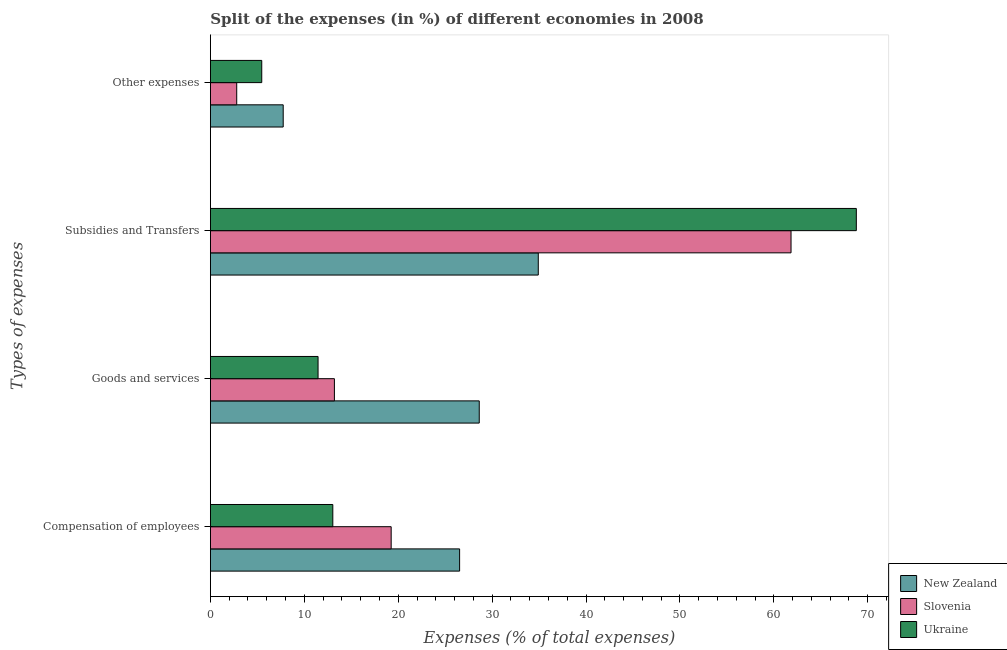Are the number of bars per tick equal to the number of legend labels?
Provide a succinct answer. Yes. What is the label of the 4th group of bars from the top?
Offer a terse response. Compensation of employees. What is the percentage of amount spent on compensation of employees in Ukraine?
Make the answer very short. 13.04. Across all countries, what is the maximum percentage of amount spent on compensation of employees?
Provide a succinct answer. 26.54. Across all countries, what is the minimum percentage of amount spent on compensation of employees?
Your answer should be compact. 13.04. In which country was the percentage of amount spent on other expenses maximum?
Your answer should be compact. New Zealand. In which country was the percentage of amount spent on subsidies minimum?
Offer a terse response. New Zealand. What is the total percentage of amount spent on other expenses in the graph?
Keep it short and to the point. 16.03. What is the difference between the percentage of amount spent on subsidies in Ukraine and that in New Zealand?
Your answer should be compact. 33.87. What is the difference between the percentage of amount spent on subsidies in Slovenia and the percentage of amount spent on goods and services in New Zealand?
Offer a terse response. 33.2. What is the average percentage of amount spent on other expenses per country?
Your answer should be very brief. 5.34. What is the difference between the percentage of amount spent on other expenses and percentage of amount spent on goods and services in Slovenia?
Your answer should be compact. -10.4. What is the ratio of the percentage of amount spent on other expenses in New Zealand to that in Ukraine?
Your answer should be very brief. 1.42. What is the difference between the highest and the second highest percentage of amount spent on goods and services?
Ensure brevity in your answer.  15.42. What is the difference between the highest and the lowest percentage of amount spent on compensation of employees?
Provide a short and direct response. 13.5. In how many countries, is the percentage of amount spent on subsidies greater than the average percentage of amount spent on subsidies taken over all countries?
Provide a short and direct response. 2. What does the 3rd bar from the top in Compensation of employees represents?
Ensure brevity in your answer.  New Zealand. What does the 3rd bar from the bottom in Other expenses represents?
Your answer should be compact. Ukraine. What is the difference between two consecutive major ticks on the X-axis?
Your answer should be compact. 10. Are the values on the major ticks of X-axis written in scientific E-notation?
Offer a terse response. No. Does the graph contain any zero values?
Make the answer very short. No. Does the graph contain grids?
Offer a terse response. No. Where does the legend appear in the graph?
Ensure brevity in your answer.  Bottom right. How many legend labels are there?
Your answer should be compact. 3. How are the legend labels stacked?
Provide a succinct answer. Vertical. What is the title of the graph?
Ensure brevity in your answer.  Split of the expenses (in %) of different economies in 2008. Does "Estonia" appear as one of the legend labels in the graph?
Offer a very short reply. No. What is the label or title of the X-axis?
Ensure brevity in your answer.  Expenses (% of total expenses). What is the label or title of the Y-axis?
Your answer should be compact. Types of expenses. What is the Expenses (% of total expenses) in New Zealand in Compensation of employees?
Make the answer very short. 26.54. What is the Expenses (% of total expenses) in Slovenia in Compensation of employees?
Make the answer very short. 19.25. What is the Expenses (% of total expenses) of Ukraine in Compensation of employees?
Make the answer very short. 13.04. What is the Expenses (% of total expenses) of New Zealand in Goods and services?
Ensure brevity in your answer.  28.63. What is the Expenses (% of total expenses) of Slovenia in Goods and services?
Ensure brevity in your answer.  13.21. What is the Expenses (% of total expenses) in Ukraine in Goods and services?
Give a very brief answer. 11.47. What is the Expenses (% of total expenses) in New Zealand in Subsidies and Transfers?
Give a very brief answer. 34.91. What is the Expenses (% of total expenses) of Slovenia in Subsidies and Transfers?
Provide a short and direct response. 61.83. What is the Expenses (% of total expenses) in Ukraine in Subsidies and Transfers?
Keep it short and to the point. 68.78. What is the Expenses (% of total expenses) in New Zealand in Other expenses?
Make the answer very short. 7.75. What is the Expenses (% of total expenses) of Slovenia in Other expenses?
Keep it short and to the point. 2.8. What is the Expenses (% of total expenses) in Ukraine in Other expenses?
Your answer should be very brief. 5.47. Across all Types of expenses, what is the maximum Expenses (% of total expenses) of New Zealand?
Offer a very short reply. 34.91. Across all Types of expenses, what is the maximum Expenses (% of total expenses) in Slovenia?
Give a very brief answer. 61.83. Across all Types of expenses, what is the maximum Expenses (% of total expenses) of Ukraine?
Give a very brief answer. 68.78. Across all Types of expenses, what is the minimum Expenses (% of total expenses) of New Zealand?
Offer a terse response. 7.75. Across all Types of expenses, what is the minimum Expenses (% of total expenses) in Slovenia?
Your answer should be very brief. 2.8. Across all Types of expenses, what is the minimum Expenses (% of total expenses) of Ukraine?
Provide a short and direct response. 5.47. What is the total Expenses (% of total expenses) of New Zealand in the graph?
Your response must be concise. 97.84. What is the total Expenses (% of total expenses) in Slovenia in the graph?
Make the answer very short. 97.09. What is the total Expenses (% of total expenses) of Ukraine in the graph?
Keep it short and to the point. 98.75. What is the difference between the Expenses (% of total expenses) of New Zealand in Compensation of employees and that in Goods and services?
Your response must be concise. -2.09. What is the difference between the Expenses (% of total expenses) in Slovenia in Compensation of employees and that in Goods and services?
Offer a terse response. 6.04. What is the difference between the Expenses (% of total expenses) of Ukraine in Compensation of employees and that in Goods and services?
Ensure brevity in your answer.  1.57. What is the difference between the Expenses (% of total expenses) of New Zealand in Compensation of employees and that in Subsidies and Transfers?
Offer a terse response. -8.38. What is the difference between the Expenses (% of total expenses) of Slovenia in Compensation of employees and that in Subsidies and Transfers?
Offer a very short reply. -42.58. What is the difference between the Expenses (% of total expenses) in Ukraine in Compensation of employees and that in Subsidies and Transfers?
Your answer should be compact. -55.74. What is the difference between the Expenses (% of total expenses) in New Zealand in Compensation of employees and that in Other expenses?
Your answer should be compact. 18.78. What is the difference between the Expenses (% of total expenses) of Slovenia in Compensation of employees and that in Other expenses?
Keep it short and to the point. 16.45. What is the difference between the Expenses (% of total expenses) in Ukraine in Compensation of employees and that in Other expenses?
Make the answer very short. 7.57. What is the difference between the Expenses (% of total expenses) in New Zealand in Goods and services and that in Subsidies and Transfers?
Offer a terse response. -6.29. What is the difference between the Expenses (% of total expenses) of Slovenia in Goods and services and that in Subsidies and Transfers?
Your answer should be very brief. -48.62. What is the difference between the Expenses (% of total expenses) of Ukraine in Goods and services and that in Subsidies and Transfers?
Your response must be concise. -57.32. What is the difference between the Expenses (% of total expenses) of New Zealand in Goods and services and that in Other expenses?
Your response must be concise. 20.88. What is the difference between the Expenses (% of total expenses) in Slovenia in Goods and services and that in Other expenses?
Make the answer very short. 10.4. What is the difference between the Expenses (% of total expenses) in Ukraine in Goods and services and that in Other expenses?
Make the answer very short. 6. What is the difference between the Expenses (% of total expenses) of New Zealand in Subsidies and Transfers and that in Other expenses?
Give a very brief answer. 27.16. What is the difference between the Expenses (% of total expenses) of Slovenia in Subsidies and Transfers and that in Other expenses?
Your answer should be very brief. 59.02. What is the difference between the Expenses (% of total expenses) in Ukraine in Subsidies and Transfers and that in Other expenses?
Your answer should be compact. 63.31. What is the difference between the Expenses (% of total expenses) of New Zealand in Compensation of employees and the Expenses (% of total expenses) of Slovenia in Goods and services?
Your response must be concise. 13.33. What is the difference between the Expenses (% of total expenses) in New Zealand in Compensation of employees and the Expenses (% of total expenses) in Ukraine in Goods and services?
Your answer should be compact. 15.07. What is the difference between the Expenses (% of total expenses) in Slovenia in Compensation of employees and the Expenses (% of total expenses) in Ukraine in Goods and services?
Give a very brief answer. 7.78. What is the difference between the Expenses (% of total expenses) in New Zealand in Compensation of employees and the Expenses (% of total expenses) in Slovenia in Subsidies and Transfers?
Make the answer very short. -35.29. What is the difference between the Expenses (% of total expenses) in New Zealand in Compensation of employees and the Expenses (% of total expenses) in Ukraine in Subsidies and Transfers?
Your answer should be compact. -42.24. What is the difference between the Expenses (% of total expenses) of Slovenia in Compensation of employees and the Expenses (% of total expenses) of Ukraine in Subsidies and Transfers?
Your answer should be compact. -49.53. What is the difference between the Expenses (% of total expenses) in New Zealand in Compensation of employees and the Expenses (% of total expenses) in Slovenia in Other expenses?
Offer a very short reply. 23.73. What is the difference between the Expenses (% of total expenses) in New Zealand in Compensation of employees and the Expenses (% of total expenses) in Ukraine in Other expenses?
Your answer should be very brief. 21.07. What is the difference between the Expenses (% of total expenses) in Slovenia in Compensation of employees and the Expenses (% of total expenses) in Ukraine in Other expenses?
Your answer should be very brief. 13.78. What is the difference between the Expenses (% of total expenses) of New Zealand in Goods and services and the Expenses (% of total expenses) of Slovenia in Subsidies and Transfers?
Provide a short and direct response. -33.2. What is the difference between the Expenses (% of total expenses) in New Zealand in Goods and services and the Expenses (% of total expenses) in Ukraine in Subsidies and Transfers?
Your answer should be very brief. -40.15. What is the difference between the Expenses (% of total expenses) of Slovenia in Goods and services and the Expenses (% of total expenses) of Ukraine in Subsidies and Transfers?
Provide a succinct answer. -55.57. What is the difference between the Expenses (% of total expenses) in New Zealand in Goods and services and the Expenses (% of total expenses) in Slovenia in Other expenses?
Your response must be concise. 25.82. What is the difference between the Expenses (% of total expenses) of New Zealand in Goods and services and the Expenses (% of total expenses) of Ukraine in Other expenses?
Provide a succinct answer. 23.16. What is the difference between the Expenses (% of total expenses) in Slovenia in Goods and services and the Expenses (% of total expenses) in Ukraine in Other expenses?
Your response must be concise. 7.74. What is the difference between the Expenses (% of total expenses) in New Zealand in Subsidies and Transfers and the Expenses (% of total expenses) in Slovenia in Other expenses?
Keep it short and to the point. 32.11. What is the difference between the Expenses (% of total expenses) in New Zealand in Subsidies and Transfers and the Expenses (% of total expenses) in Ukraine in Other expenses?
Your response must be concise. 29.45. What is the difference between the Expenses (% of total expenses) of Slovenia in Subsidies and Transfers and the Expenses (% of total expenses) of Ukraine in Other expenses?
Ensure brevity in your answer.  56.36. What is the average Expenses (% of total expenses) of New Zealand per Types of expenses?
Your response must be concise. 24.46. What is the average Expenses (% of total expenses) of Slovenia per Types of expenses?
Offer a very short reply. 24.27. What is the average Expenses (% of total expenses) of Ukraine per Types of expenses?
Provide a succinct answer. 24.69. What is the difference between the Expenses (% of total expenses) of New Zealand and Expenses (% of total expenses) of Slovenia in Compensation of employees?
Keep it short and to the point. 7.29. What is the difference between the Expenses (% of total expenses) in New Zealand and Expenses (% of total expenses) in Ukraine in Compensation of employees?
Keep it short and to the point. 13.5. What is the difference between the Expenses (% of total expenses) of Slovenia and Expenses (% of total expenses) of Ukraine in Compensation of employees?
Offer a terse response. 6.21. What is the difference between the Expenses (% of total expenses) in New Zealand and Expenses (% of total expenses) in Slovenia in Goods and services?
Offer a terse response. 15.42. What is the difference between the Expenses (% of total expenses) of New Zealand and Expenses (% of total expenses) of Ukraine in Goods and services?
Your answer should be very brief. 17.16. What is the difference between the Expenses (% of total expenses) in Slovenia and Expenses (% of total expenses) in Ukraine in Goods and services?
Provide a succinct answer. 1.74. What is the difference between the Expenses (% of total expenses) in New Zealand and Expenses (% of total expenses) in Slovenia in Subsidies and Transfers?
Provide a short and direct response. -26.91. What is the difference between the Expenses (% of total expenses) of New Zealand and Expenses (% of total expenses) of Ukraine in Subsidies and Transfers?
Your answer should be very brief. -33.87. What is the difference between the Expenses (% of total expenses) of Slovenia and Expenses (% of total expenses) of Ukraine in Subsidies and Transfers?
Offer a terse response. -6.95. What is the difference between the Expenses (% of total expenses) of New Zealand and Expenses (% of total expenses) of Slovenia in Other expenses?
Keep it short and to the point. 4.95. What is the difference between the Expenses (% of total expenses) in New Zealand and Expenses (% of total expenses) in Ukraine in Other expenses?
Provide a succinct answer. 2.28. What is the difference between the Expenses (% of total expenses) of Slovenia and Expenses (% of total expenses) of Ukraine in Other expenses?
Ensure brevity in your answer.  -2.67. What is the ratio of the Expenses (% of total expenses) of New Zealand in Compensation of employees to that in Goods and services?
Your response must be concise. 0.93. What is the ratio of the Expenses (% of total expenses) in Slovenia in Compensation of employees to that in Goods and services?
Provide a short and direct response. 1.46. What is the ratio of the Expenses (% of total expenses) of Ukraine in Compensation of employees to that in Goods and services?
Provide a short and direct response. 1.14. What is the ratio of the Expenses (% of total expenses) in New Zealand in Compensation of employees to that in Subsidies and Transfers?
Provide a succinct answer. 0.76. What is the ratio of the Expenses (% of total expenses) of Slovenia in Compensation of employees to that in Subsidies and Transfers?
Your response must be concise. 0.31. What is the ratio of the Expenses (% of total expenses) in Ukraine in Compensation of employees to that in Subsidies and Transfers?
Your answer should be compact. 0.19. What is the ratio of the Expenses (% of total expenses) in New Zealand in Compensation of employees to that in Other expenses?
Your answer should be very brief. 3.42. What is the ratio of the Expenses (% of total expenses) of Slovenia in Compensation of employees to that in Other expenses?
Your answer should be compact. 6.86. What is the ratio of the Expenses (% of total expenses) of Ukraine in Compensation of employees to that in Other expenses?
Your answer should be compact. 2.38. What is the ratio of the Expenses (% of total expenses) of New Zealand in Goods and services to that in Subsidies and Transfers?
Your answer should be very brief. 0.82. What is the ratio of the Expenses (% of total expenses) of Slovenia in Goods and services to that in Subsidies and Transfers?
Your answer should be compact. 0.21. What is the ratio of the Expenses (% of total expenses) in New Zealand in Goods and services to that in Other expenses?
Your response must be concise. 3.69. What is the ratio of the Expenses (% of total expenses) in Slovenia in Goods and services to that in Other expenses?
Ensure brevity in your answer.  4.71. What is the ratio of the Expenses (% of total expenses) of Ukraine in Goods and services to that in Other expenses?
Your answer should be very brief. 2.1. What is the ratio of the Expenses (% of total expenses) of New Zealand in Subsidies and Transfers to that in Other expenses?
Offer a terse response. 4.5. What is the ratio of the Expenses (% of total expenses) in Slovenia in Subsidies and Transfers to that in Other expenses?
Make the answer very short. 22.05. What is the ratio of the Expenses (% of total expenses) of Ukraine in Subsidies and Transfers to that in Other expenses?
Offer a very short reply. 12.57. What is the difference between the highest and the second highest Expenses (% of total expenses) in New Zealand?
Offer a terse response. 6.29. What is the difference between the highest and the second highest Expenses (% of total expenses) of Slovenia?
Keep it short and to the point. 42.58. What is the difference between the highest and the second highest Expenses (% of total expenses) in Ukraine?
Provide a succinct answer. 55.74. What is the difference between the highest and the lowest Expenses (% of total expenses) in New Zealand?
Offer a very short reply. 27.16. What is the difference between the highest and the lowest Expenses (% of total expenses) in Slovenia?
Keep it short and to the point. 59.02. What is the difference between the highest and the lowest Expenses (% of total expenses) in Ukraine?
Provide a short and direct response. 63.31. 